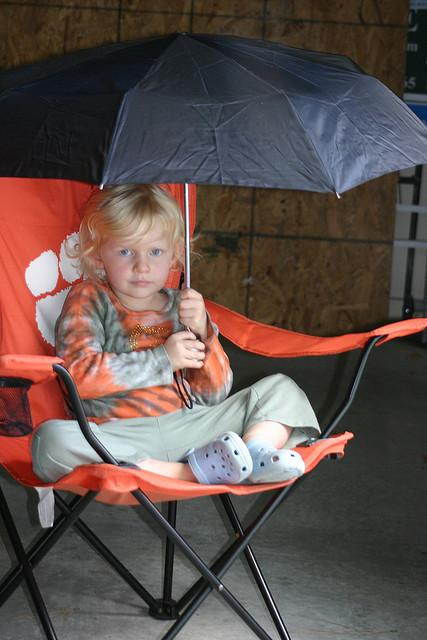What minimalizing action can this chair be made to do?

Choices:
A) disappear
B) shrink
C) blow up
D) fold up fold up 